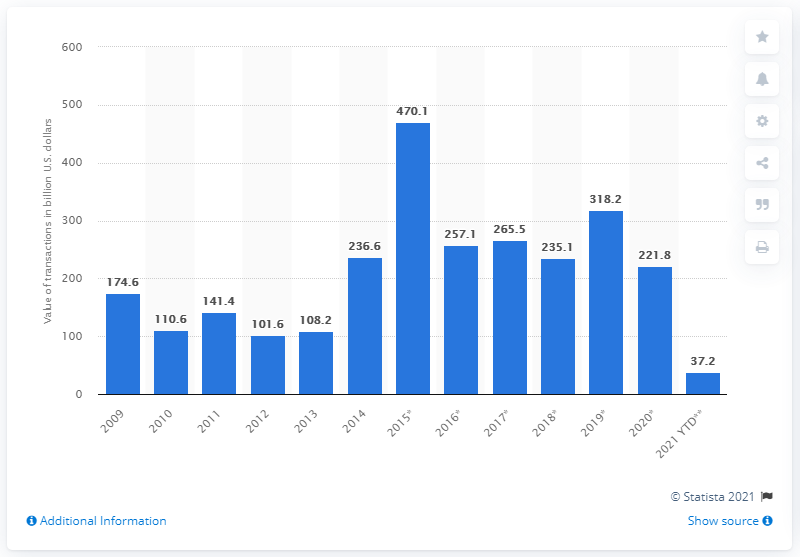Draw attention to some important aspects in this diagram. The value of merger and acquisition transactions in the United States in 2020 was 221.8. 